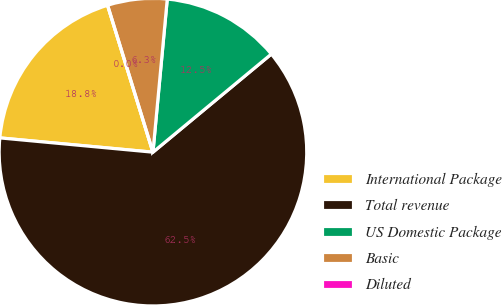Convert chart to OTSL. <chart><loc_0><loc_0><loc_500><loc_500><pie_chart><fcel>International Package<fcel>Total revenue<fcel>US Domestic Package<fcel>Basic<fcel>Diluted<nl><fcel>18.75%<fcel>62.49%<fcel>12.5%<fcel>6.25%<fcel>0.0%<nl></chart> 